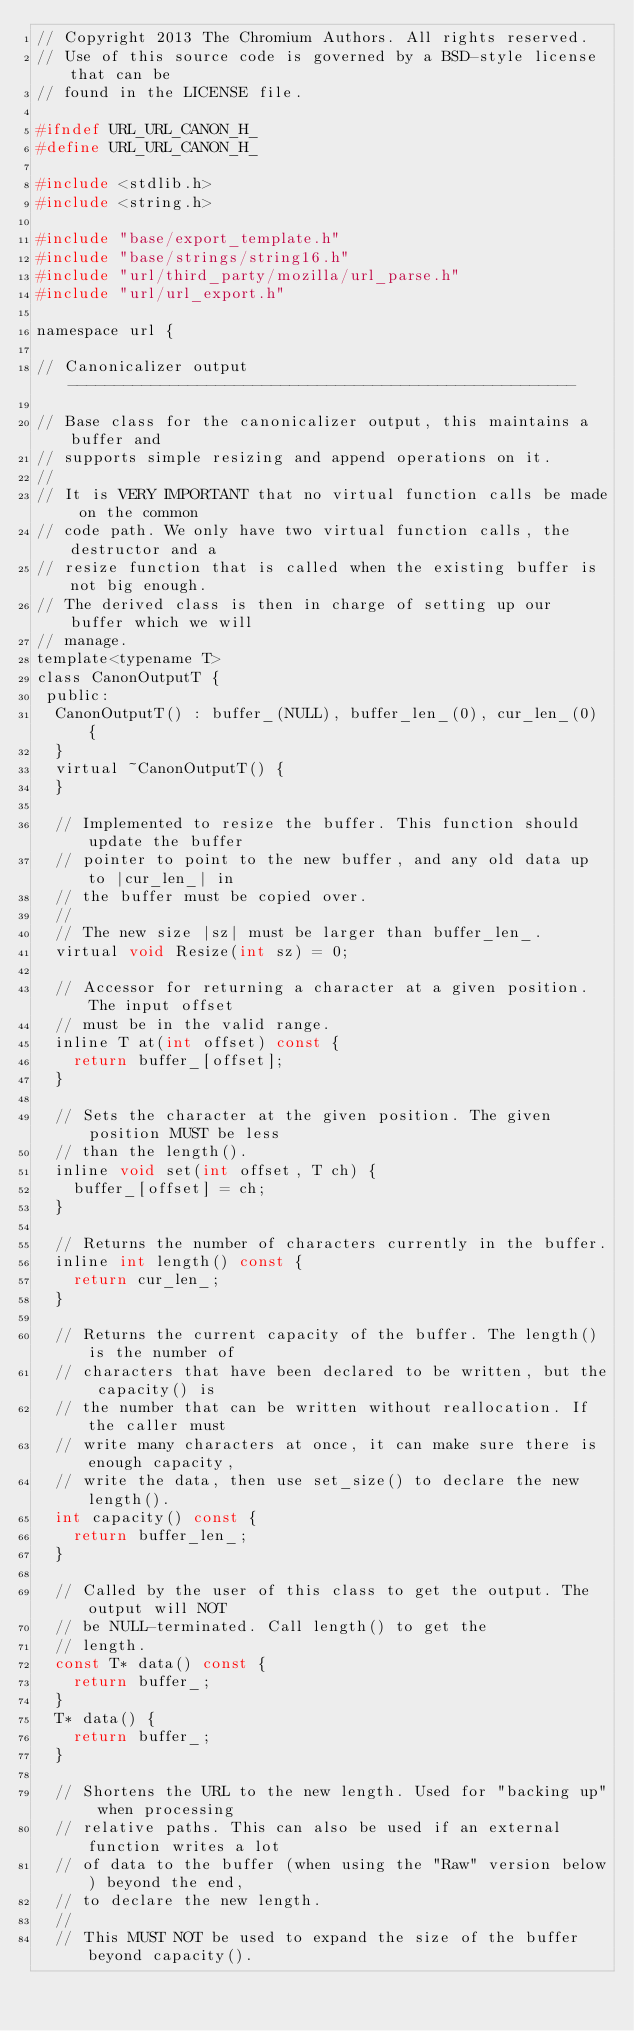<code> <loc_0><loc_0><loc_500><loc_500><_C_>// Copyright 2013 The Chromium Authors. All rights reserved.
// Use of this source code is governed by a BSD-style license that can be
// found in the LICENSE file.

#ifndef URL_URL_CANON_H_
#define URL_URL_CANON_H_

#include <stdlib.h>
#include <string.h>

#include "base/export_template.h"
#include "base/strings/string16.h"
#include "url/third_party/mozilla/url_parse.h"
#include "url/url_export.h"

namespace url {

// Canonicalizer output -------------------------------------------------------

// Base class for the canonicalizer output, this maintains a buffer and
// supports simple resizing and append operations on it.
//
// It is VERY IMPORTANT that no virtual function calls be made on the common
// code path. We only have two virtual function calls, the destructor and a
// resize function that is called when the existing buffer is not big enough.
// The derived class is then in charge of setting up our buffer which we will
// manage.
template<typename T>
class CanonOutputT {
 public:
  CanonOutputT() : buffer_(NULL), buffer_len_(0), cur_len_(0) {
  }
  virtual ~CanonOutputT() {
  }

  // Implemented to resize the buffer. This function should update the buffer
  // pointer to point to the new buffer, and any old data up to |cur_len_| in
  // the buffer must be copied over.
  //
  // The new size |sz| must be larger than buffer_len_.
  virtual void Resize(int sz) = 0;

  // Accessor for returning a character at a given position. The input offset
  // must be in the valid range.
  inline T at(int offset) const {
    return buffer_[offset];
  }

  // Sets the character at the given position. The given position MUST be less
  // than the length().
  inline void set(int offset, T ch) {
    buffer_[offset] = ch;
  }

  // Returns the number of characters currently in the buffer.
  inline int length() const {
    return cur_len_;
  }

  // Returns the current capacity of the buffer. The length() is the number of
  // characters that have been declared to be written, but the capacity() is
  // the number that can be written without reallocation. If the caller must
  // write many characters at once, it can make sure there is enough capacity,
  // write the data, then use set_size() to declare the new length().
  int capacity() const {
    return buffer_len_;
  }

  // Called by the user of this class to get the output. The output will NOT
  // be NULL-terminated. Call length() to get the
  // length.
  const T* data() const {
    return buffer_;
  }
  T* data() {
    return buffer_;
  }

  // Shortens the URL to the new length. Used for "backing up" when processing
  // relative paths. This can also be used if an external function writes a lot
  // of data to the buffer (when using the "Raw" version below) beyond the end,
  // to declare the new length.
  //
  // This MUST NOT be used to expand the size of the buffer beyond capacity().</code> 